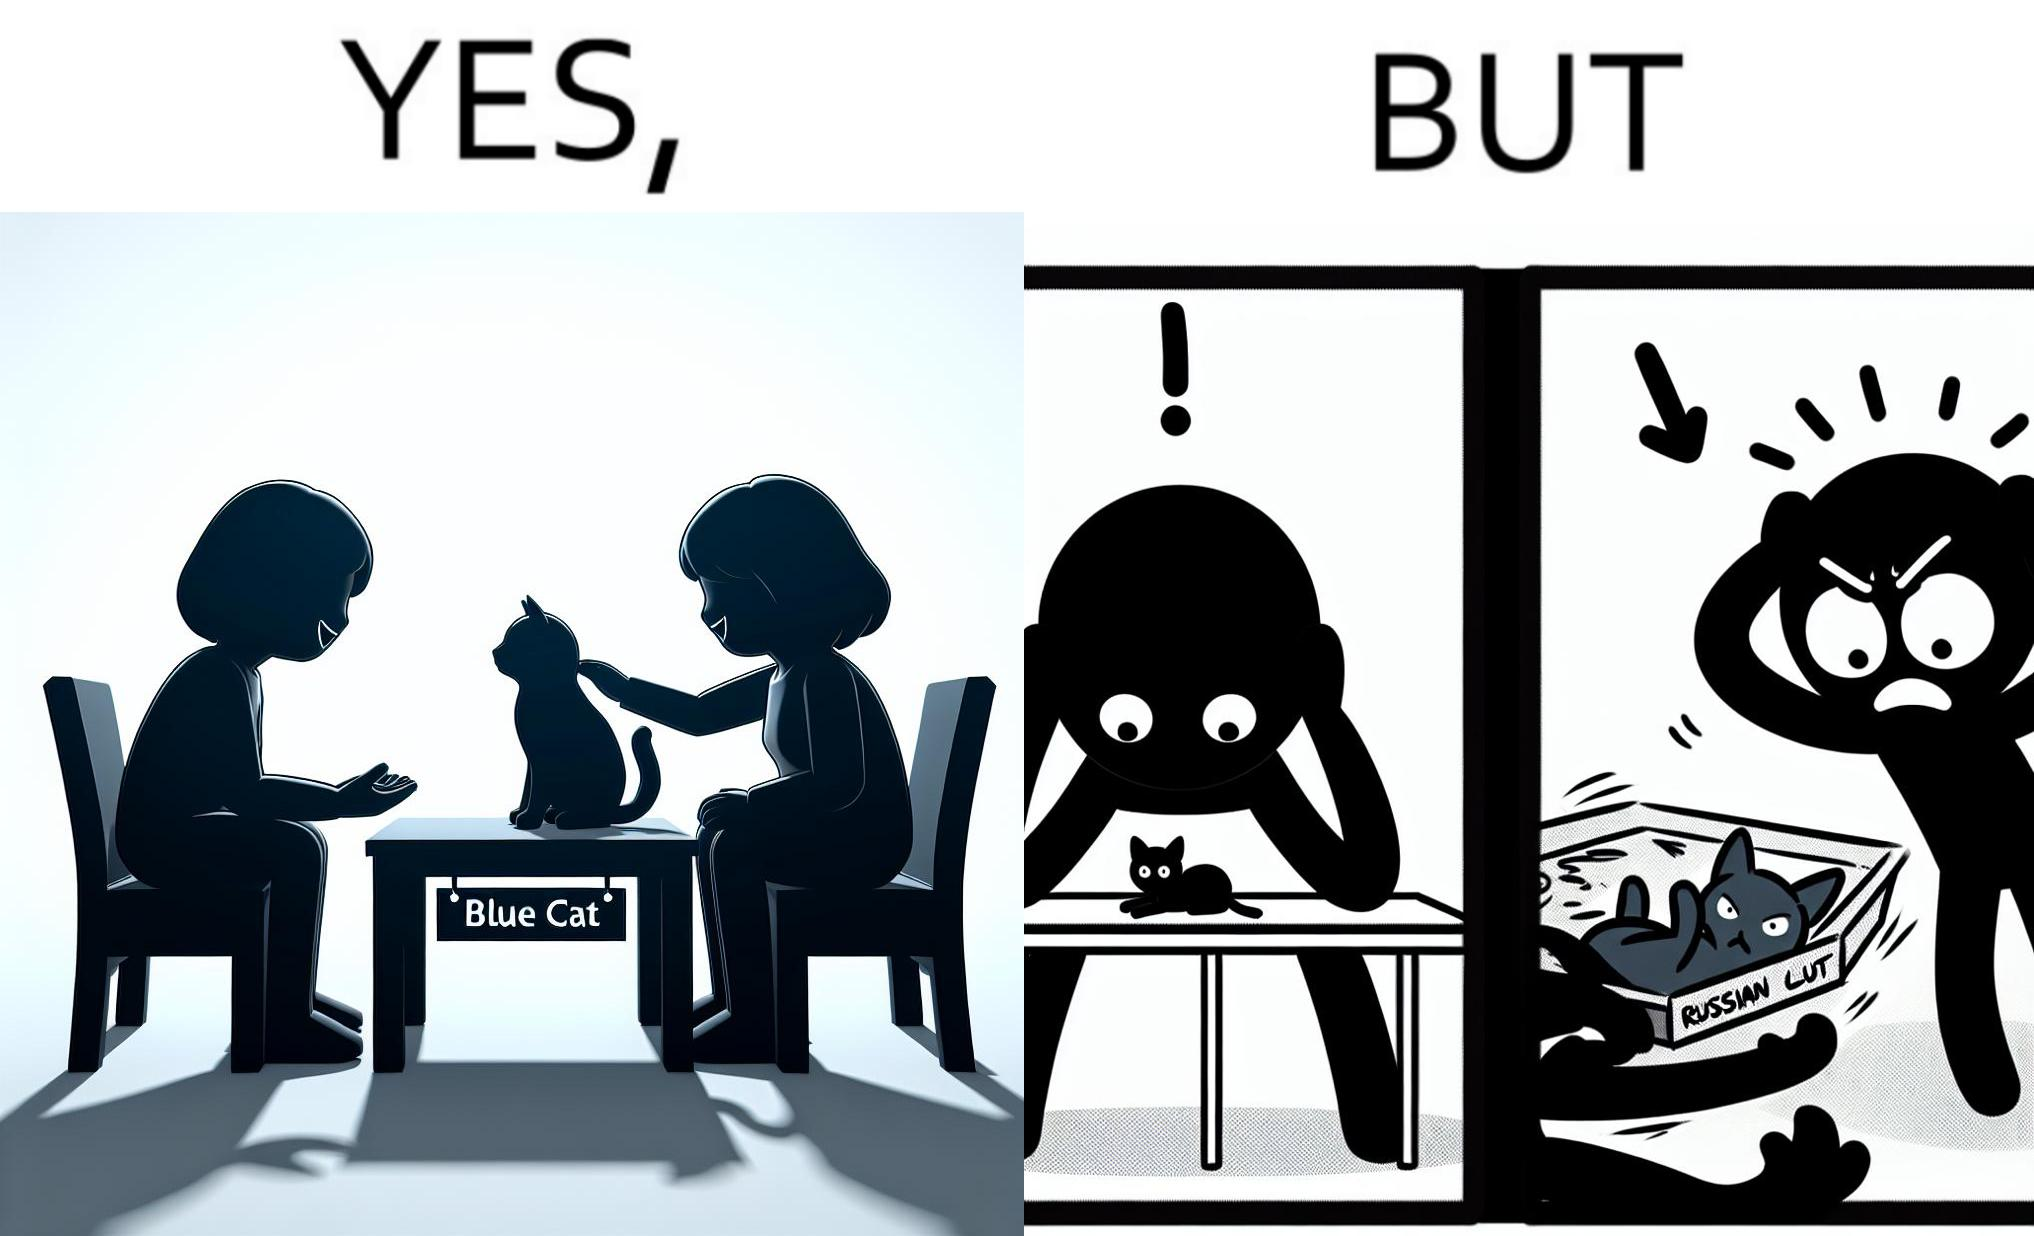Does this image contain satire or humor? Yes, this image is satirical. 